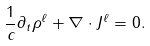Convert formula to latex. <formula><loc_0><loc_0><loc_500><loc_500>\frac { 1 } { c } \partial _ { t } \rho ^ { \ell } + \nabla \cdot J ^ { \ell } = 0 .</formula> 